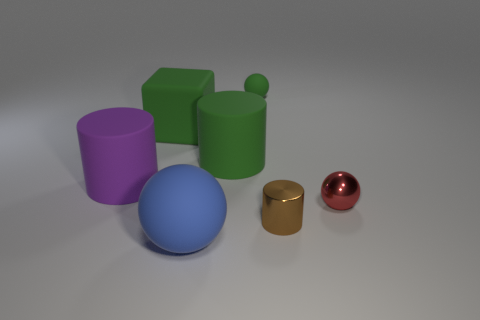Does the big block have the same color as the small rubber thing?
Offer a very short reply. Yes. What is the shape of the green thing to the left of the matte ball that is in front of the big purple thing that is behind the blue object?
Ensure brevity in your answer.  Cube. What is the size of the cylinder that is on the left side of the metallic cylinder and on the right side of the large block?
Make the answer very short. Large. Is the number of brown things less than the number of big purple spheres?
Provide a succinct answer. No. There is a cylinder that is to the left of the blue thing; how big is it?
Ensure brevity in your answer.  Large. There is a large rubber object that is to the right of the big green block and behind the big matte ball; what is its shape?
Ensure brevity in your answer.  Cylinder. There is a purple rubber thing that is the same shape as the brown object; what is its size?
Provide a succinct answer. Large. How many tiny brown cylinders have the same material as the red object?
Your answer should be compact. 1. There is a small rubber sphere; is it the same color as the big matte cylinder on the right side of the green matte cube?
Keep it short and to the point. Yes. Is the number of big balls greater than the number of big blue rubber cylinders?
Offer a very short reply. Yes. 